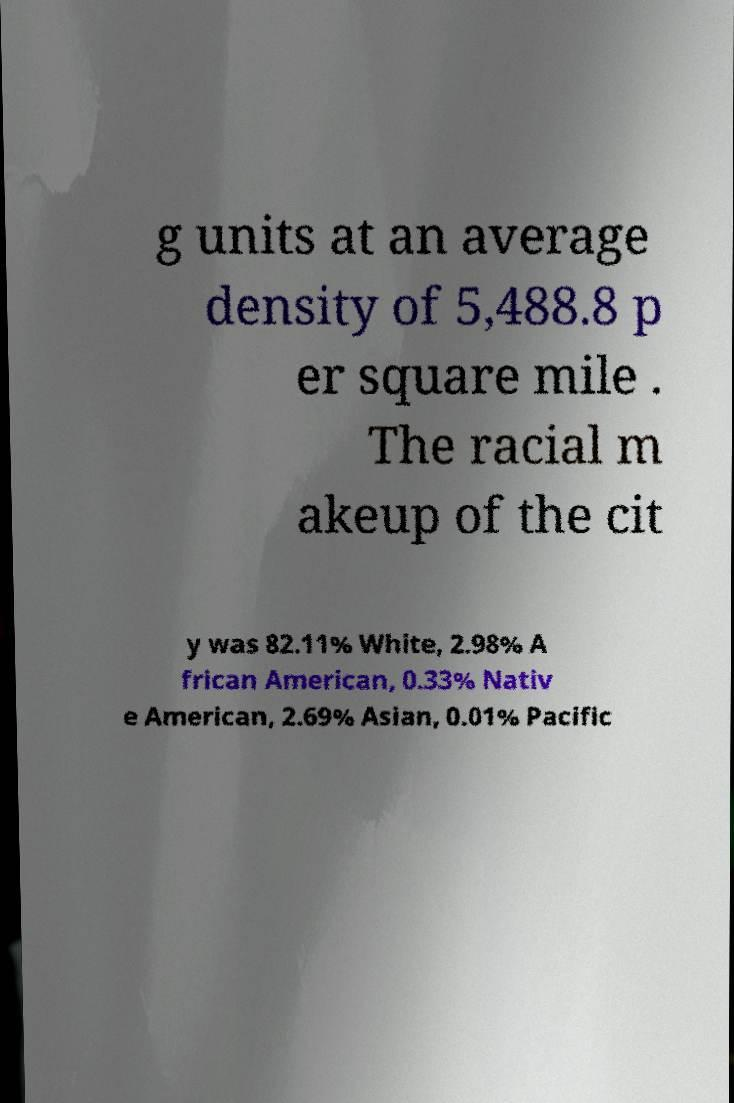Can you read and provide the text displayed in the image?This photo seems to have some interesting text. Can you extract and type it out for me? g units at an average density of 5,488.8 p er square mile . The racial m akeup of the cit y was 82.11% White, 2.98% A frican American, 0.33% Nativ e American, 2.69% Asian, 0.01% Pacific 